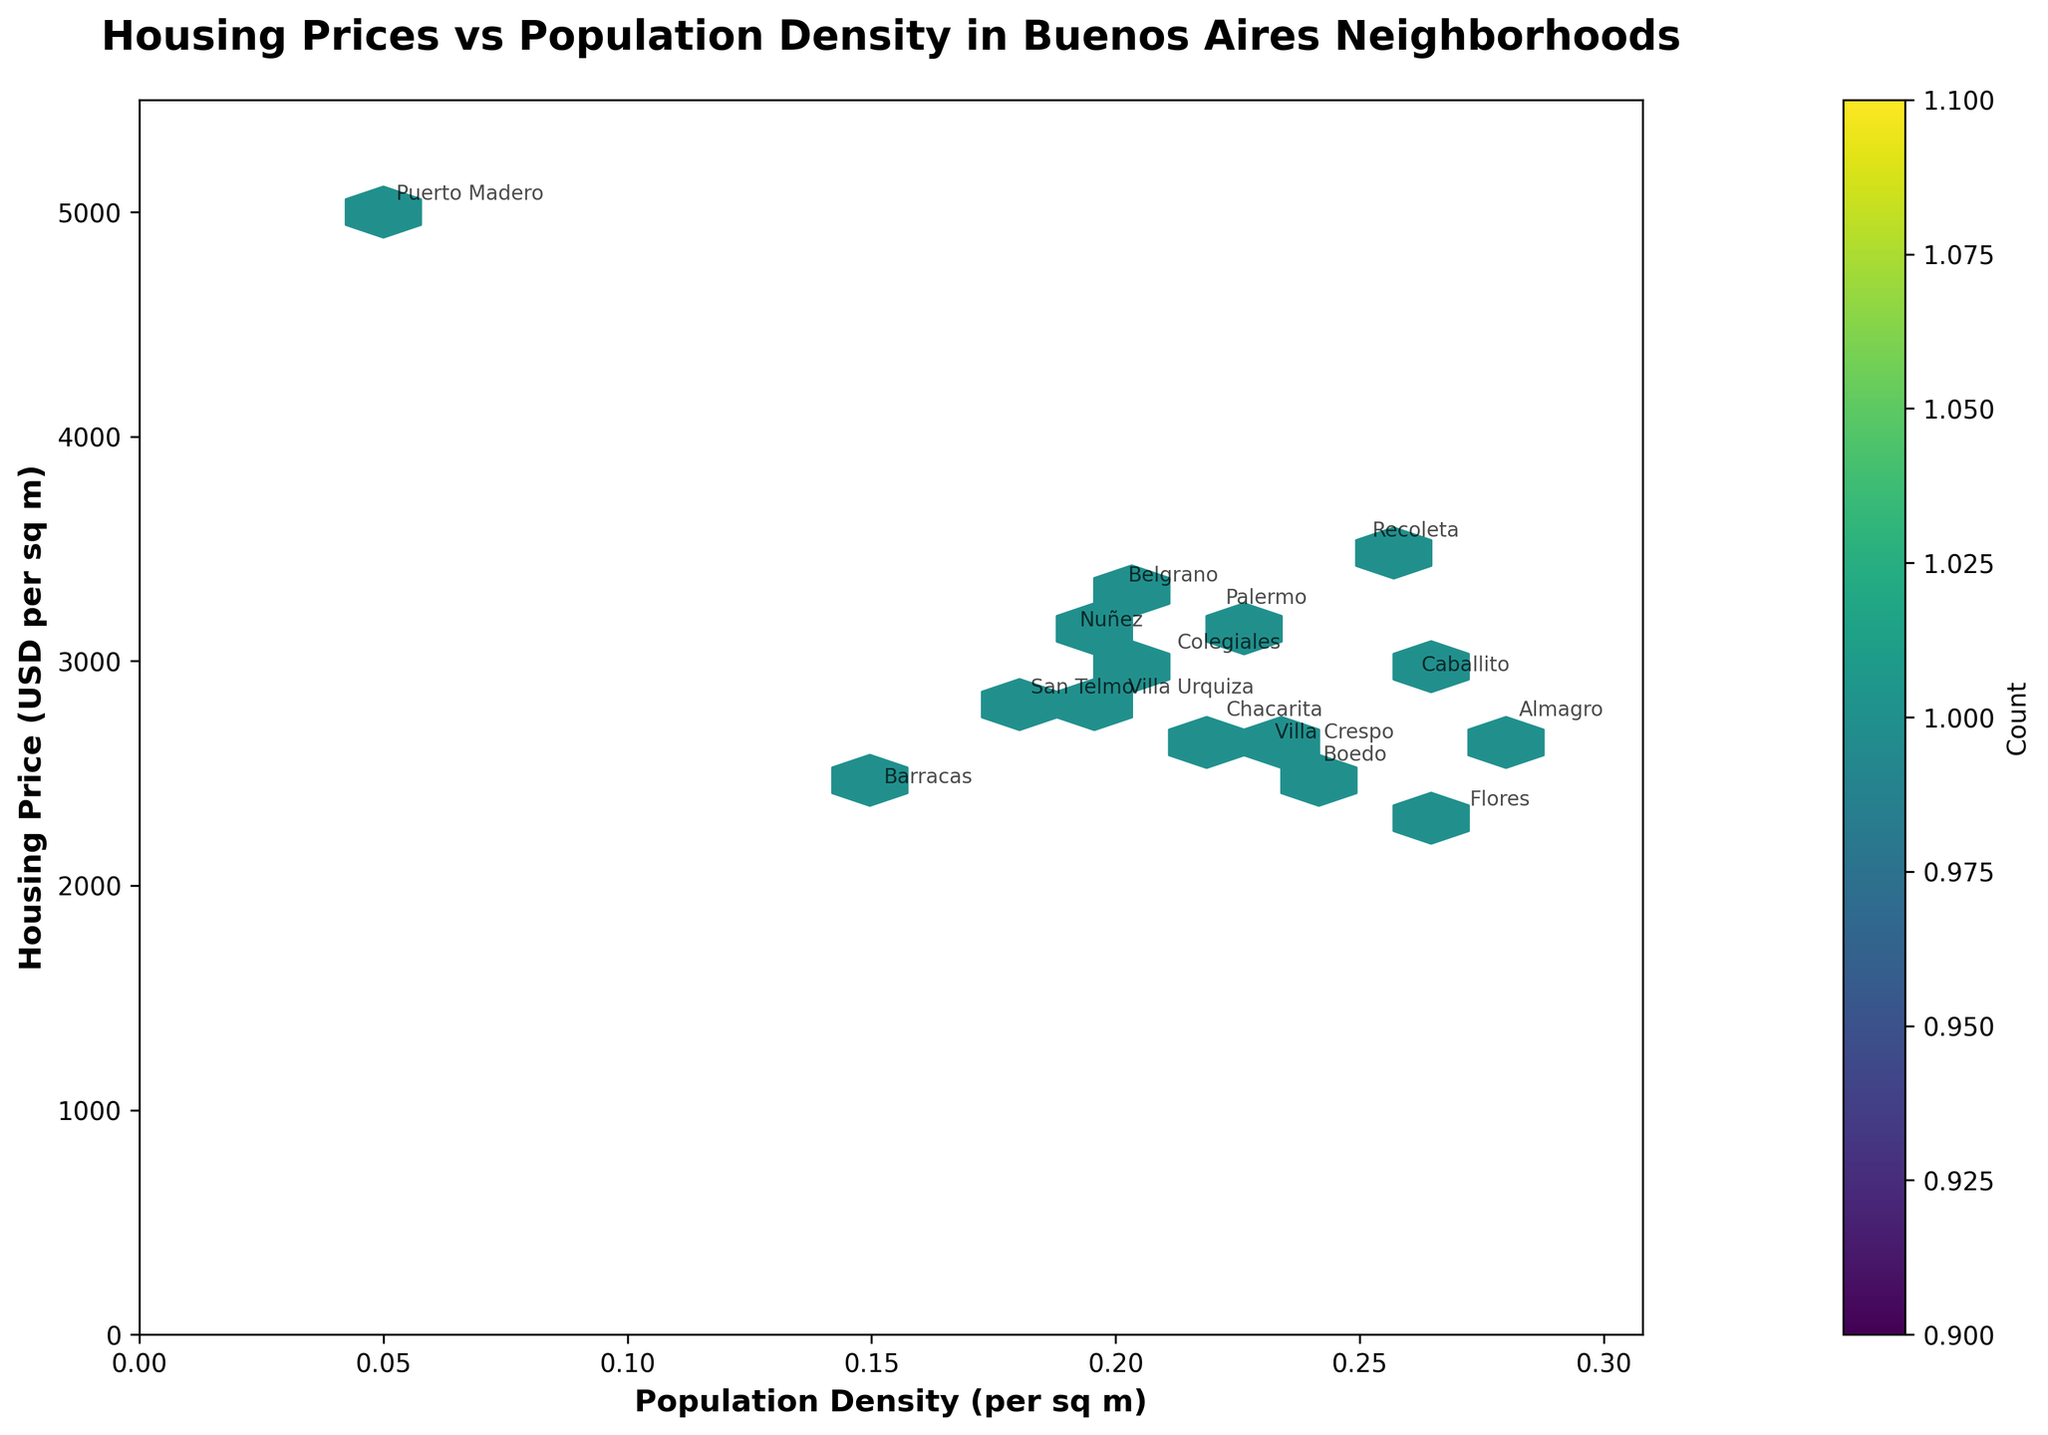What is the title of the plot? The title is displayed at the top of the plot, typically in a larger and bolder font compared to other text elements.
Answer: Housing Prices vs Population Density in Buenos Aires Neighborhoods Which neighborhood has the highest housing price per square meter? The highest housing price per square meter is indicated by the point that is the highest on the y-axis. Annotations next to the points identify the neighborhoods.
Answer: Puerto Madero Which axis represents population density? Axes are labeled to indicate what they represent. Check the label on each axis to determine what they represent.
Answer: The x-axis What are the housing price and population density values for Almagro? Locate the point annotated with "Almagro." Follow the grid lines to the x-axis and y-axis to find the respective values.
Answer: Approximately 2700 USD per sqm and 0.28 per sqm Which neighborhood has the lowest population density? The lowest population density corresponds to the point farthest to the left on the x-axis. Annotations clarify the neighborhood.
Answer: Puerto Madero Compare the housing prices of Caballito and Villa Crespo. Which is higher? Locate the points for Caballito and Villa Crespo, noting their y-axis values. Compare these values to see which is higher.
Answer: Caballito Is there a general trend between housing prices and population density? Observe the overall distribution of points and see if there is a pattern such as clustering or a directional trend to the points to derive insights.
Answer: Generally, higher densities do not always correspond to higher prices; higher housing prices tend to be at lower densities Calculate the difference in housing prices between the neighborhoods with the highest and lowest prices. Identify the highest (Puerto Madero) and lowest (Flores) housing prices from their positions on the y-axis. Subtract the lowest from the highest price.
Answer: 5000 - 2300 = 2700 USD per sqm Which neighborhood has both a high housing price and a relatively high population density? Look for points that are high on both the x-axis and y-axis. Higher population density means further right and higher housing price means higher up.
Answer: Recoleta How many neighborhoods are represented in the plot? Each neighborhood is a distinct point marked with an annotation. Count the number of unique annotations on the plot.
Answer: 15 